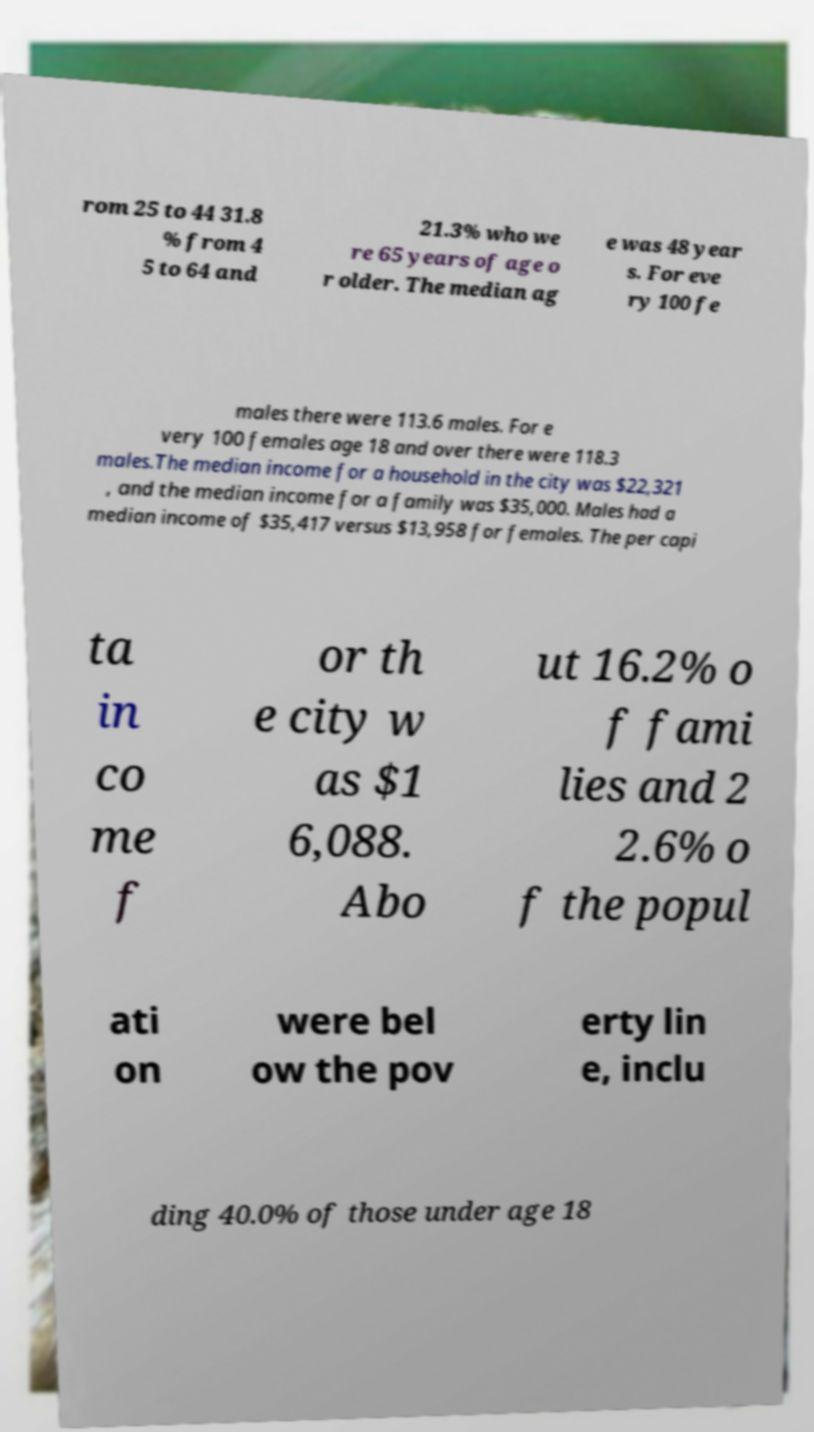For documentation purposes, I need the text within this image transcribed. Could you provide that? rom 25 to 44 31.8 % from 4 5 to 64 and 21.3% who we re 65 years of age o r older. The median ag e was 48 year s. For eve ry 100 fe males there were 113.6 males. For e very 100 females age 18 and over there were 118.3 males.The median income for a household in the city was $22,321 , and the median income for a family was $35,000. Males had a median income of $35,417 versus $13,958 for females. The per capi ta in co me f or th e city w as $1 6,088. Abo ut 16.2% o f fami lies and 2 2.6% o f the popul ati on were bel ow the pov erty lin e, inclu ding 40.0% of those under age 18 